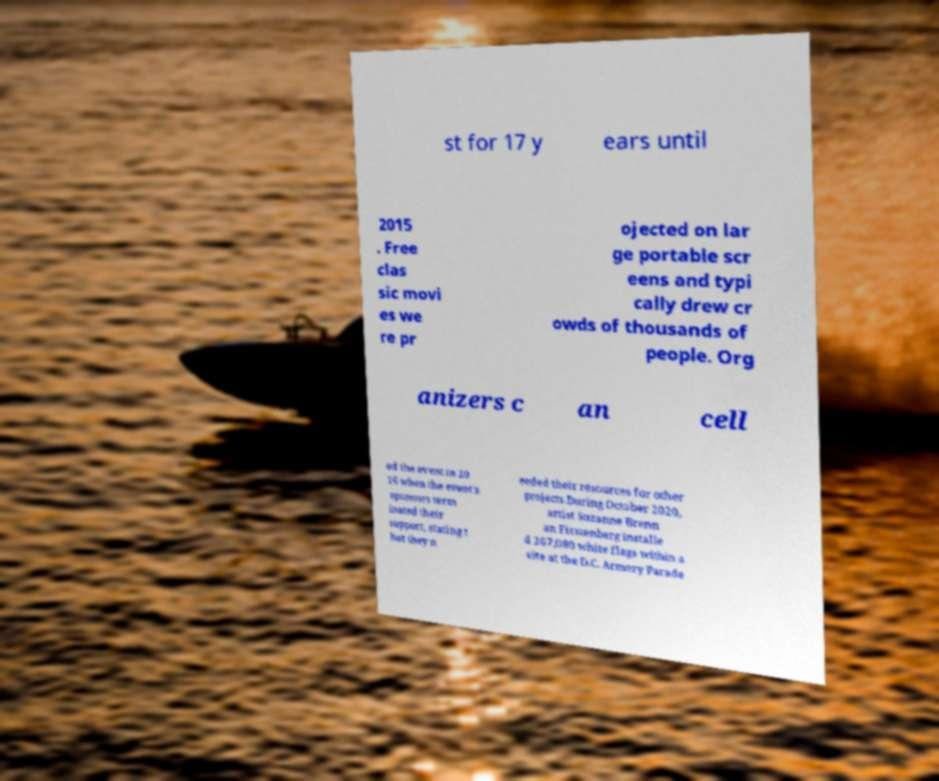There's text embedded in this image that I need extracted. Can you transcribe it verbatim? st for 17 y ears until 2015 . Free clas sic movi es we re pr ojected on lar ge portable scr eens and typi cally drew cr owds of thousands of people. Org anizers c an cell ed the event in 20 16 when the event's sponsors term inated their support, stating t hat they n eeded their resources for other projects.During October 2020, artist Suzanne Brenn an Firstenberg installe d 267,080 white flags within a site at the D.C. Armory Parade 